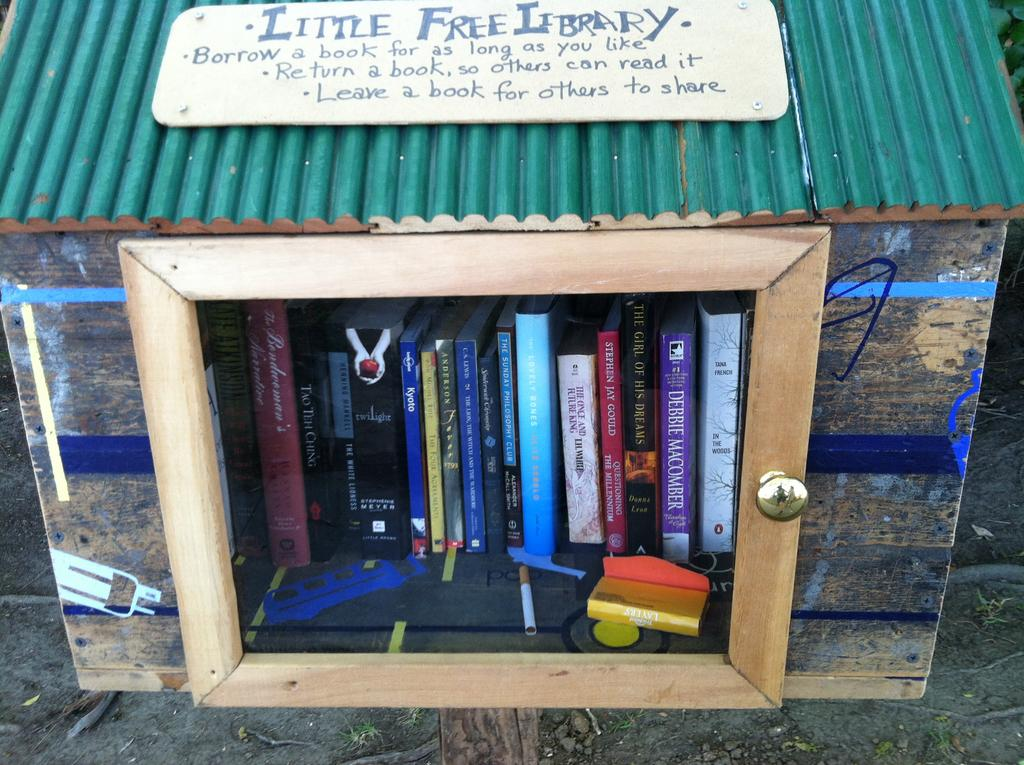Provide a one-sentence caption for the provided image. You can borrow books at any time from the Little Free Library. 